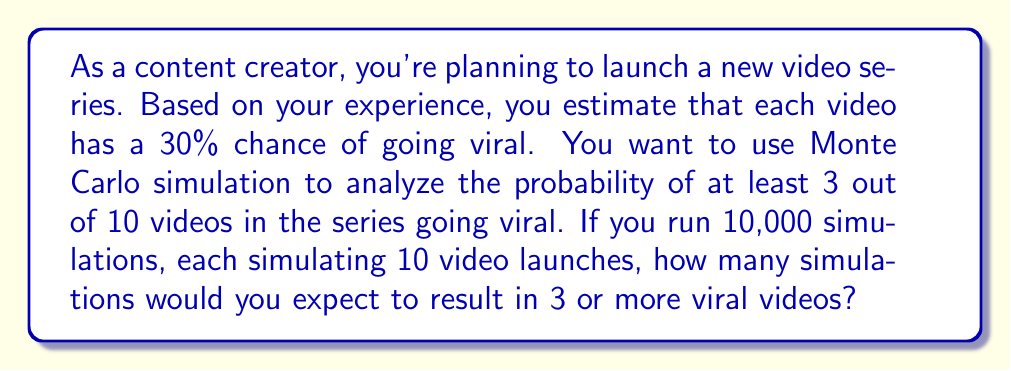What is the answer to this math problem? Let's approach this step-by-step:

1) First, we need to understand what we're simulating:
   - Each simulation represents 10 video launches
   - Each video has a 30% chance of going viral
   - We're interested in cases where 3 or more videos go viral

2) This scenario follows a binomial distribution with parameters:
   $n = 10$ (number of trials)
   $p = 0.30$ (probability of success)

3) The probability of exactly $k$ successes in $n$ trials is given by the binomial probability formula:

   $$P(X = k) = \binom{n}{k} p^k (1-p)^{n-k}$$

4) We want the probability of 3 or more successes, which is:

   $$P(X \geq 3) = 1 - [P(X = 0) + P(X = 1) + P(X = 2)]$$

5) Calculating this:

   $$P(X \geq 3) = 1 - [\binom{10}{0}0.3^0 0.7^{10} + \binom{10}{1}0.3^1 0.7^9 + \binom{10}{2}0.3^2 0.7^8]$$

6) Solving this (you can use a calculator or computer for this step):

   $$P(X \geq 3) \approx 0.6496$$

7) In a Monte Carlo simulation with 10,000 runs, we would expect this probability to be reflected in the proportion of successful simulations.

8) Therefore, the expected number of simulations resulting in 3 or more viral videos is:

   $$10,000 \times 0.6496 = 6,496$$
Answer: 6,496 simulations 